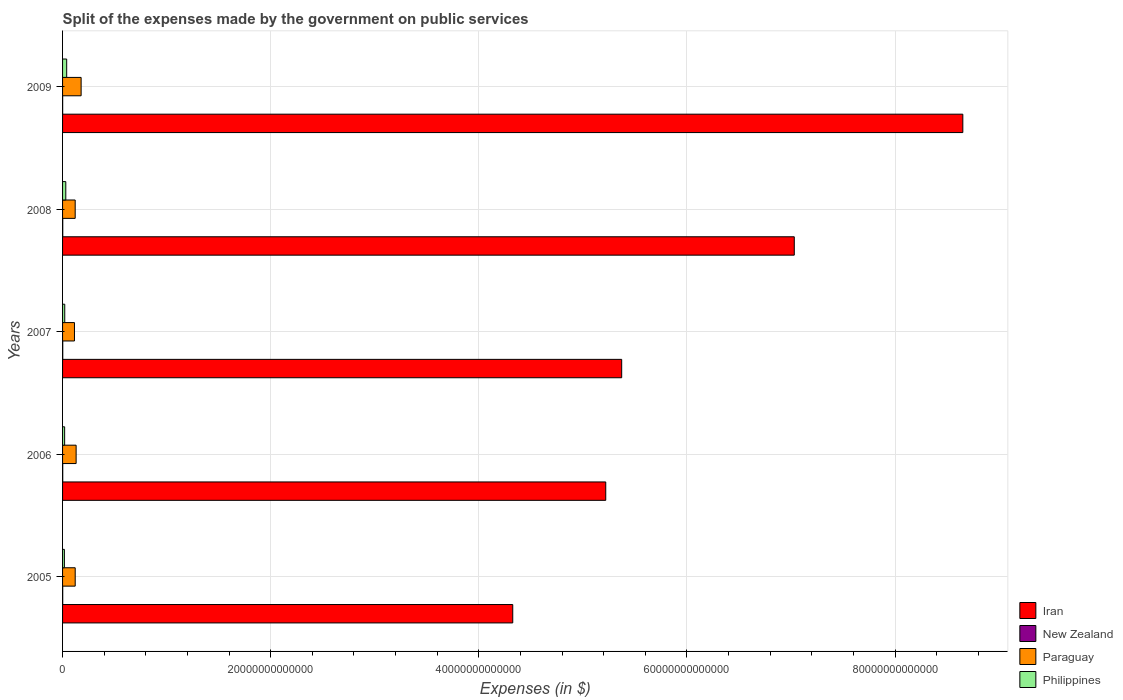How many groups of bars are there?
Make the answer very short. 5. Are the number of bars per tick equal to the number of legend labels?
Provide a succinct answer. Yes. Are the number of bars on each tick of the Y-axis equal?
Your response must be concise. Yes. How many bars are there on the 1st tick from the top?
Ensure brevity in your answer.  4. In how many cases, is the number of bars for a given year not equal to the number of legend labels?
Offer a terse response. 0. What is the expenses made by the government on public services in Paraguay in 2007?
Your answer should be very brief. 1.14e+12. Across all years, what is the maximum expenses made by the government on public services in Philippines?
Provide a succinct answer. 3.95e+11. Across all years, what is the minimum expenses made by the government on public services in Philippines?
Make the answer very short. 1.75e+11. What is the total expenses made by the government on public services in Paraguay in the graph?
Ensure brevity in your answer.  6.66e+12. What is the difference between the expenses made by the government on public services in New Zealand in 2005 and that in 2009?
Provide a short and direct response. 5.75e+09. What is the difference between the expenses made by the government on public services in Philippines in 2009 and the expenses made by the government on public services in New Zealand in 2007?
Make the answer very short. 3.78e+11. What is the average expenses made by the government on public services in Philippines per year?
Offer a very short reply. 2.58e+11. In the year 2008, what is the difference between the expenses made by the government on public services in Iran and expenses made by the government on public services in New Zealand?
Offer a very short reply. 7.03e+13. In how many years, is the expenses made by the government on public services in Philippines greater than 72000000000000 $?
Your answer should be compact. 0. What is the ratio of the expenses made by the government on public services in Philippines in 2006 to that in 2007?
Ensure brevity in your answer.  0.95. Is the expenses made by the government on public services in Iran in 2008 less than that in 2009?
Provide a short and direct response. Yes. Is the difference between the expenses made by the government on public services in Iran in 2005 and 2006 greater than the difference between the expenses made by the government on public services in New Zealand in 2005 and 2006?
Your answer should be compact. No. What is the difference between the highest and the second highest expenses made by the government on public services in Iran?
Provide a succinct answer. 1.62e+13. What is the difference between the highest and the lowest expenses made by the government on public services in Iran?
Make the answer very short. 4.32e+13. Is it the case that in every year, the sum of the expenses made by the government on public services in New Zealand and expenses made by the government on public services in Iran is greater than the sum of expenses made by the government on public services in Paraguay and expenses made by the government on public services in Philippines?
Give a very brief answer. Yes. What does the 3rd bar from the top in 2008 represents?
Your answer should be very brief. New Zealand. What does the 3rd bar from the bottom in 2007 represents?
Your response must be concise. Paraguay. How many bars are there?
Ensure brevity in your answer.  20. How many years are there in the graph?
Offer a very short reply. 5. What is the difference between two consecutive major ticks on the X-axis?
Provide a short and direct response. 2.00e+13. Are the values on the major ticks of X-axis written in scientific E-notation?
Offer a very short reply. No. Does the graph contain any zero values?
Offer a terse response. No. How are the legend labels stacked?
Offer a very short reply. Vertical. What is the title of the graph?
Make the answer very short. Split of the expenses made by the government on public services. What is the label or title of the X-axis?
Your answer should be very brief. Expenses (in $). What is the Expenses (in $) of Iran in 2005?
Offer a very short reply. 4.33e+13. What is the Expenses (in $) in New Zealand in 2005?
Provide a succinct answer. 1.40e+1. What is the Expenses (in $) of Paraguay in 2005?
Your response must be concise. 1.21e+12. What is the Expenses (in $) of Philippines in 2005?
Give a very brief answer. 1.75e+11. What is the Expenses (in $) of Iran in 2006?
Offer a terse response. 5.22e+13. What is the Expenses (in $) in New Zealand in 2006?
Your answer should be very brief. 1.58e+1. What is the Expenses (in $) of Paraguay in 2006?
Offer a terse response. 1.30e+12. What is the Expenses (in $) of Philippines in 2006?
Your answer should be compact. 1.99e+11. What is the Expenses (in $) of Iran in 2007?
Your answer should be compact. 5.37e+13. What is the Expenses (in $) of New Zealand in 2007?
Give a very brief answer. 1.77e+1. What is the Expenses (in $) in Paraguay in 2007?
Keep it short and to the point. 1.14e+12. What is the Expenses (in $) of Philippines in 2007?
Provide a succinct answer. 2.09e+11. What is the Expenses (in $) in Iran in 2008?
Keep it short and to the point. 7.03e+13. What is the Expenses (in $) in New Zealand in 2008?
Your response must be concise. 1.77e+1. What is the Expenses (in $) in Paraguay in 2008?
Your answer should be very brief. 1.21e+12. What is the Expenses (in $) of Philippines in 2008?
Offer a terse response. 3.11e+11. What is the Expenses (in $) of Iran in 2009?
Provide a succinct answer. 8.65e+13. What is the Expenses (in $) in New Zealand in 2009?
Offer a very short reply. 8.30e+09. What is the Expenses (in $) of Paraguay in 2009?
Offer a terse response. 1.78e+12. What is the Expenses (in $) of Philippines in 2009?
Provide a succinct answer. 3.95e+11. Across all years, what is the maximum Expenses (in $) in Iran?
Keep it short and to the point. 8.65e+13. Across all years, what is the maximum Expenses (in $) in New Zealand?
Offer a very short reply. 1.77e+1. Across all years, what is the maximum Expenses (in $) of Paraguay?
Keep it short and to the point. 1.78e+12. Across all years, what is the maximum Expenses (in $) of Philippines?
Offer a very short reply. 3.95e+11. Across all years, what is the minimum Expenses (in $) of Iran?
Provide a succinct answer. 4.33e+13. Across all years, what is the minimum Expenses (in $) in New Zealand?
Give a very brief answer. 8.30e+09. Across all years, what is the minimum Expenses (in $) in Paraguay?
Make the answer very short. 1.14e+12. Across all years, what is the minimum Expenses (in $) of Philippines?
Your answer should be compact. 1.75e+11. What is the total Expenses (in $) in Iran in the graph?
Make the answer very short. 3.06e+14. What is the total Expenses (in $) in New Zealand in the graph?
Provide a short and direct response. 7.35e+1. What is the total Expenses (in $) in Paraguay in the graph?
Give a very brief answer. 6.66e+12. What is the total Expenses (in $) of Philippines in the graph?
Ensure brevity in your answer.  1.29e+12. What is the difference between the Expenses (in $) in Iran in 2005 and that in 2006?
Ensure brevity in your answer.  -8.94e+12. What is the difference between the Expenses (in $) of New Zealand in 2005 and that in 2006?
Ensure brevity in your answer.  -1.75e+09. What is the difference between the Expenses (in $) in Paraguay in 2005 and that in 2006?
Provide a short and direct response. -8.92e+1. What is the difference between the Expenses (in $) of Philippines in 2005 and that in 2006?
Keep it short and to the point. -2.40e+1. What is the difference between the Expenses (in $) of Iran in 2005 and that in 2007?
Your answer should be very brief. -1.05e+13. What is the difference between the Expenses (in $) of New Zealand in 2005 and that in 2007?
Provide a short and direct response. -3.63e+09. What is the difference between the Expenses (in $) in Paraguay in 2005 and that in 2007?
Make the answer very short. 6.98e+1. What is the difference between the Expenses (in $) of Philippines in 2005 and that in 2007?
Your answer should be compact. -3.42e+1. What is the difference between the Expenses (in $) of Iran in 2005 and that in 2008?
Give a very brief answer. -2.71e+13. What is the difference between the Expenses (in $) in New Zealand in 2005 and that in 2008?
Give a very brief answer. -3.65e+09. What is the difference between the Expenses (in $) of Paraguay in 2005 and that in 2008?
Offer a terse response. 6.40e+08. What is the difference between the Expenses (in $) of Philippines in 2005 and that in 2008?
Your response must be concise. -1.36e+11. What is the difference between the Expenses (in $) of Iran in 2005 and that in 2009?
Your response must be concise. -4.32e+13. What is the difference between the Expenses (in $) of New Zealand in 2005 and that in 2009?
Ensure brevity in your answer.  5.75e+09. What is the difference between the Expenses (in $) in Paraguay in 2005 and that in 2009?
Keep it short and to the point. -5.70e+11. What is the difference between the Expenses (in $) of Philippines in 2005 and that in 2009?
Offer a terse response. -2.20e+11. What is the difference between the Expenses (in $) of Iran in 2006 and that in 2007?
Offer a very short reply. -1.53e+12. What is the difference between the Expenses (in $) of New Zealand in 2006 and that in 2007?
Your answer should be very brief. -1.88e+09. What is the difference between the Expenses (in $) in Paraguay in 2006 and that in 2007?
Keep it short and to the point. 1.59e+11. What is the difference between the Expenses (in $) in Philippines in 2006 and that in 2007?
Your answer should be compact. -1.02e+1. What is the difference between the Expenses (in $) of Iran in 2006 and that in 2008?
Your answer should be very brief. -1.81e+13. What is the difference between the Expenses (in $) of New Zealand in 2006 and that in 2008?
Make the answer very short. -1.90e+09. What is the difference between the Expenses (in $) in Paraguay in 2006 and that in 2008?
Offer a very short reply. 8.98e+1. What is the difference between the Expenses (in $) in Philippines in 2006 and that in 2008?
Provide a short and direct response. -1.12e+11. What is the difference between the Expenses (in $) in Iran in 2006 and that in 2009?
Your answer should be very brief. -3.43e+13. What is the difference between the Expenses (in $) in New Zealand in 2006 and that in 2009?
Make the answer very short. 7.49e+09. What is the difference between the Expenses (in $) in Paraguay in 2006 and that in 2009?
Give a very brief answer. -4.81e+11. What is the difference between the Expenses (in $) of Philippines in 2006 and that in 2009?
Your response must be concise. -1.96e+11. What is the difference between the Expenses (in $) of Iran in 2007 and that in 2008?
Offer a very short reply. -1.66e+13. What is the difference between the Expenses (in $) of New Zealand in 2007 and that in 2008?
Give a very brief answer. -1.65e+07. What is the difference between the Expenses (in $) of Paraguay in 2007 and that in 2008?
Your answer should be very brief. -6.91e+1. What is the difference between the Expenses (in $) in Philippines in 2007 and that in 2008?
Your response must be concise. -1.01e+11. What is the difference between the Expenses (in $) in Iran in 2007 and that in 2009?
Ensure brevity in your answer.  -3.28e+13. What is the difference between the Expenses (in $) of New Zealand in 2007 and that in 2009?
Ensure brevity in your answer.  9.38e+09. What is the difference between the Expenses (in $) in Paraguay in 2007 and that in 2009?
Give a very brief answer. -6.40e+11. What is the difference between the Expenses (in $) in Philippines in 2007 and that in 2009?
Your answer should be very brief. -1.86e+11. What is the difference between the Expenses (in $) in Iran in 2008 and that in 2009?
Keep it short and to the point. -1.62e+13. What is the difference between the Expenses (in $) of New Zealand in 2008 and that in 2009?
Make the answer very short. 9.39e+09. What is the difference between the Expenses (in $) in Paraguay in 2008 and that in 2009?
Your answer should be compact. -5.70e+11. What is the difference between the Expenses (in $) of Philippines in 2008 and that in 2009?
Your answer should be very brief. -8.45e+1. What is the difference between the Expenses (in $) of Iran in 2005 and the Expenses (in $) of New Zealand in 2006?
Provide a short and direct response. 4.32e+13. What is the difference between the Expenses (in $) of Iran in 2005 and the Expenses (in $) of Paraguay in 2006?
Your answer should be very brief. 4.20e+13. What is the difference between the Expenses (in $) of Iran in 2005 and the Expenses (in $) of Philippines in 2006?
Your answer should be very brief. 4.31e+13. What is the difference between the Expenses (in $) in New Zealand in 2005 and the Expenses (in $) in Paraguay in 2006?
Provide a succinct answer. -1.29e+12. What is the difference between the Expenses (in $) of New Zealand in 2005 and the Expenses (in $) of Philippines in 2006?
Offer a very short reply. -1.85e+11. What is the difference between the Expenses (in $) in Paraguay in 2005 and the Expenses (in $) in Philippines in 2006?
Your response must be concise. 1.01e+12. What is the difference between the Expenses (in $) of Iran in 2005 and the Expenses (in $) of New Zealand in 2007?
Keep it short and to the point. 4.32e+13. What is the difference between the Expenses (in $) of Iran in 2005 and the Expenses (in $) of Paraguay in 2007?
Ensure brevity in your answer.  4.21e+13. What is the difference between the Expenses (in $) in Iran in 2005 and the Expenses (in $) in Philippines in 2007?
Give a very brief answer. 4.30e+13. What is the difference between the Expenses (in $) of New Zealand in 2005 and the Expenses (in $) of Paraguay in 2007?
Provide a succinct answer. -1.13e+12. What is the difference between the Expenses (in $) of New Zealand in 2005 and the Expenses (in $) of Philippines in 2007?
Offer a terse response. -1.95e+11. What is the difference between the Expenses (in $) of Paraguay in 2005 and the Expenses (in $) of Philippines in 2007?
Offer a very short reply. 1.00e+12. What is the difference between the Expenses (in $) of Iran in 2005 and the Expenses (in $) of New Zealand in 2008?
Your response must be concise. 4.32e+13. What is the difference between the Expenses (in $) in Iran in 2005 and the Expenses (in $) in Paraguay in 2008?
Provide a short and direct response. 4.20e+13. What is the difference between the Expenses (in $) in Iran in 2005 and the Expenses (in $) in Philippines in 2008?
Offer a very short reply. 4.29e+13. What is the difference between the Expenses (in $) in New Zealand in 2005 and the Expenses (in $) in Paraguay in 2008?
Provide a succinct answer. -1.20e+12. What is the difference between the Expenses (in $) in New Zealand in 2005 and the Expenses (in $) in Philippines in 2008?
Your response must be concise. -2.97e+11. What is the difference between the Expenses (in $) of Paraguay in 2005 and the Expenses (in $) of Philippines in 2008?
Keep it short and to the point. 9.03e+11. What is the difference between the Expenses (in $) of Iran in 2005 and the Expenses (in $) of New Zealand in 2009?
Provide a short and direct response. 4.33e+13. What is the difference between the Expenses (in $) of Iran in 2005 and the Expenses (in $) of Paraguay in 2009?
Offer a very short reply. 4.15e+13. What is the difference between the Expenses (in $) in Iran in 2005 and the Expenses (in $) in Philippines in 2009?
Provide a succinct answer. 4.29e+13. What is the difference between the Expenses (in $) of New Zealand in 2005 and the Expenses (in $) of Paraguay in 2009?
Your response must be concise. -1.77e+12. What is the difference between the Expenses (in $) in New Zealand in 2005 and the Expenses (in $) in Philippines in 2009?
Keep it short and to the point. -3.81e+11. What is the difference between the Expenses (in $) in Paraguay in 2005 and the Expenses (in $) in Philippines in 2009?
Give a very brief answer. 8.18e+11. What is the difference between the Expenses (in $) in Iran in 2006 and the Expenses (in $) in New Zealand in 2007?
Offer a very short reply. 5.22e+13. What is the difference between the Expenses (in $) of Iran in 2006 and the Expenses (in $) of Paraguay in 2007?
Ensure brevity in your answer.  5.11e+13. What is the difference between the Expenses (in $) of Iran in 2006 and the Expenses (in $) of Philippines in 2007?
Provide a succinct answer. 5.20e+13. What is the difference between the Expenses (in $) of New Zealand in 2006 and the Expenses (in $) of Paraguay in 2007?
Offer a very short reply. -1.13e+12. What is the difference between the Expenses (in $) in New Zealand in 2006 and the Expenses (in $) in Philippines in 2007?
Keep it short and to the point. -1.94e+11. What is the difference between the Expenses (in $) of Paraguay in 2006 and the Expenses (in $) of Philippines in 2007?
Provide a short and direct response. 1.09e+12. What is the difference between the Expenses (in $) in Iran in 2006 and the Expenses (in $) in New Zealand in 2008?
Give a very brief answer. 5.22e+13. What is the difference between the Expenses (in $) in Iran in 2006 and the Expenses (in $) in Paraguay in 2008?
Your answer should be compact. 5.10e+13. What is the difference between the Expenses (in $) in Iran in 2006 and the Expenses (in $) in Philippines in 2008?
Keep it short and to the point. 5.19e+13. What is the difference between the Expenses (in $) in New Zealand in 2006 and the Expenses (in $) in Paraguay in 2008?
Provide a short and direct response. -1.20e+12. What is the difference between the Expenses (in $) in New Zealand in 2006 and the Expenses (in $) in Philippines in 2008?
Keep it short and to the point. -2.95e+11. What is the difference between the Expenses (in $) in Paraguay in 2006 and the Expenses (in $) in Philippines in 2008?
Ensure brevity in your answer.  9.92e+11. What is the difference between the Expenses (in $) in Iran in 2006 and the Expenses (in $) in New Zealand in 2009?
Your response must be concise. 5.22e+13. What is the difference between the Expenses (in $) in Iran in 2006 and the Expenses (in $) in Paraguay in 2009?
Provide a succinct answer. 5.04e+13. What is the difference between the Expenses (in $) of Iran in 2006 and the Expenses (in $) of Philippines in 2009?
Provide a succinct answer. 5.18e+13. What is the difference between the Expenses (in $) in New Zealand in 2006 and the Expenses (in $) in Paraguay in 2009?
Offer a terse response. -1.77e+12. What is the difference between the Expenses (in $) of New Zealand in 2006 and the Expenses (in $) of Philippines in 2009?
Give a very brief answer. -3.80e+11. What is the difference between the Expenses (in $) of Paraguay in 2006 and the Expenses (in $) of Philippines in 2009?
Offer a terse response. 9.07e+11. What is the difference between the Expenses (in $) in Iran in 2007 and the Expenses (in $) in New Zealand in 2008?
Your response must be concise. 5.37e+13. What is the difference between the Expenses (in $) in Iran in 2007 and the Expenses (in $) in Paraguay in 2008?
Make the answer very short. 5.25e+13. What is the difference between the Expenses (in $) in Iran in 2007 and the Expenses (in $) in Philippines in 2008?
Provide a short and direct response. 5.34e+13. What is the difference between the Expenses (in $) of New Zealand in 2007 and the Expenses (in $) of Paraguay in 2008?
Your response must be concise. -1.20e+12. What is the difference between the Expenses (in $) of New Zealand in 2007 and the Expenses (in $) of Philippines in 2008?
Your response must be concise. -2.93e+11. What is the difference between the Expenses (in $) of Paraguay in 2007 and the Expenses (in $) of Philippines in 2008?
Your answer should be very brief. 8.33e+11. What is the difference between the Expenses (in $) of Iran in 2007 and the Expenses (in $) of New Zealand in 2009?
Your answer should be compact. 5.37e+13. What is the difference between the Expenses (in $) in Iran in 2007 and the Expenses (in $) in Paraguay in 2009?
Provide a short and direct response. 5.19e+13. What is the difference between the Expenses (in $) in Iran in 2007 and the Expenses (in $) in Philippines in 2009?
Your answer should be very brief. 5.33e+13. What is the difference between the Expenses (in $) of New Zealand in 2007 and the Expenses (in $) of Paraguay in 2009?
Keep it short and to the point. -1.77e+12. What is the difference between the Expenses (in $) in New Zealand in 2007 and the Expenses (in $) in Philippines in 2009?
Offer a very short reply. -3.78e+11. What is the difference between the Expenses (in $) in Paraguay in 2007 and the Expenses (in $) in Philippines in 2009?
Provide a succinct answer. 7.48e+11. What is the difference between the Expenses (in $) in Iran in 2008 and the Expenses (in $) in New Zealand in 2009?
Give a very brief answer. 7.03e+13. What is the difference between the Expenses (in $) of Iran in 2008 and the Expenses (in $) of Paraguay in 2009?
Your response must be concise. 6.85e+13. What is the difference between the Expenses (in $) of Iran in 2008 and the Expenses (in $) of Philippines in 2009?
Make the answer very short. 6.99e+13. What is the difference between the Expenses (in $) of New Zealand in 2008 and the Expenses (in $) of Paraguay in 2009?
Give a very brief answer. -1.77e+12. What is the difference between the Expenses (in $) in New Zealand in 2008 and the Expenses (in $) in Philippines in 2009?
Provide a succinct answer. -3.78e+11. What is the difference between the Expenses (in $) of Paraguay in 2008 and the Expenses (in $) of Philippines in 2009?
Your answer should be compact. 8.18e+11. What is the average Expenses (in $) in Iran per year?
Provide a short and direct response. 6.12e+13. What is the average Expenses (in $) in New Zealand per year?
Make the answer very short. 1.47e+1. What is the average Expenses (in $) of Paraguay per year?
Make the answer very short. 1.33e+12. What is the average Expenses (in $) of Philippines per year?
Your response must be concise. 2.58e+11. In the year 2005, what is the difference between the Expenses (in $) in Iran and Expenses (in $) in New Zealand?
Make the answer very short. 4.32e+13. In the year 2005, what is the difference between the Expenses (in $) of Iran and Expenses (in $) of Paraguay?
Offer a terse response. 4.20e+13. In the year 2005, what is the difference between the Expenses (in $) in Iran and Expenses (in $) in Philippines?
Provide a succinct answer. 4.31e+13. In the year 2005, what is the difference between the Expenses (in $) of New Zealand and Expenses (in $) of Paraguay?
Make the answer very short. -1.20e+12. In the year 2005, what is the difference between the Expenses (in $) of New Zealand and Expenses (in $) of Philippines?
Make the answer very short. -1.61e+11. In the year 2005, what is the difference between the Expenses (in $) in Paraguay and Expenses (in $) in Philippines?
Make the answer very short. 1.04e+12. In the year 2006, what is the difference between the Expenses (in $) in Iran and Expenses (in $) in New Zealand?
Your answer should be very brief. 5.22e+13. In the year 2006, what is the difference between the Expenses (in $) of Iran and Expenses (in $) of Paraguay?
Offer a terse response. 5.09e+13. In the year 2006, what is the difference between the Expenses (in $) of Iran and Expenses (in $) of Philippines?
Your answer should be very brief. 5.20e+13. In the year 2006, what is the difference between the Expenses (in $) in New Zealand and Expenses (in $) in Paraguay?
Keep it short and to the point. -1.29e+12. In the year 2006, what is the difference between the Expenses (in $) of New Zealand and Expenses (in $) of Philippines?
Your response must be concise. -1.83e+11. In the year 2006, what is the difference between the Expenses (in $) in Paraguay and Expenses (in $) in Philippines?
Offer a very short reply. 1.10e+12. In the year 2007, what is the difference between the Expenses (in $) of Iran and Expenses (in $) of New Zealand?
Make the answer very short. 5.37e+13. In the year 2007, what is the difference between the Expenses (in $) in Iran and Expenses (in $) in Paraguay?
Make the answer very short. 5.26e+13. In the year 2007, what is the difference between the Expenses (in $) in Iran and Expenses (in $) in Philippines?
Offer a very short reply. 5.35e+13. In the year 2007, what is the difference between the Expenses (in $) in New Zealand and Expenses (in $) in Paraguay?
Make the answer very short. -1.13e+12. In the year 2007, what is the difference between the Expenses (in $) of New Zealand and Expenses (in $) of Philippines?
Your answer should be compact. -1.92e+11. In the year 2007, what is the difference between the Expenses (in $) in Paraguay and Expenses (in $) in Philippines?
Keep it short and to the point. 9.34e+11. In the year 2008, what is the difference between the Expenses (in $) in Iran and Expenses (in $) in New Zealand?
Provide a succinct answer. 7.03e+13. In the year 2008, what is the difference between the Expenses (in $) in Iran and Expenses (in $) in Paraguay?
Offer a very short reply. 6.91e+13. In the year 2008, what is the difference between the Expenses (in $) in Iran and Expenses (in $) in Philippines?
Provide a succinct answer. 7.00e+13. In the year 2008, what is the difference between the Expenses (in $) of New Zealand and Expenses (in $) of Paraguay?
Make the answer very short. -1.20e+12. In the year 2008, what is the difference between the Expenses (in $) in New Zealand and Expenses (in $) in Philippines?
Your response must be concise. -2.93e+11. In the year 2008, what is the difference between the Expenses (in $) in Paraguay and Expenses (in $) in Philippines?
Make the answer very short. 9.02e+11. In the year 2009, what is the difference between the Expenses (in $) of Iran and Expenses (in $) of New Zealand?
Ensure brevity in your answer.  8.65e+13. In the year 2009, what is the difference between the Expenses (in $) of Iran and Expenses (in $) of Paraguay?
Provide a succinct answer. 8.47e+13. In the year 2009, what is the difference between the Expenses (in $) of Iran and Expenses (in $) of Philippines?
Make the answer very short. 8.61e+13. In the year 2009, what is the difference between the Expenses (in $) of New Zealand and Expenses (in $) of Paraguay?
Your answer should be compact. -1.78e+12. In the year 2009, what is the difference between the Expenses (in $) of New Zealand and Expenses (in $) of Philippines?
Offer a very short reply. -3.87e+11. In the year 2009, what is the difference between the Expenses (in $) of Paraguay and Expenses (in $) of Philippines?
Ensure brevity in your answer.  1.39e+12. What is the ratio of the Expenses (in $) in Iran in 2005 to that in 2006?
Provide a short and direct response. 0.83. What is the ratio of the Expenses (in $) of New Zealand in 2005 to that in 2006?
Your answer should be compact. 0.89. What is the ratio of the Expenses (in $) of Paraguay in 2005 to that in 2006?
Keep it short and to the point. 0.93. What is the ratio of the Expenses (in $) in Philippines in 2005 to that in 2006?
Your answer should be compact. 0.88. What is the ratio of the Expenses (in $) of Iran in 2005 to that in 2007?
Offer a terse response. 0.81. What is the ratio of the Expenses (in $) in New Zealand in 2005 to that in 2007?
Provide a short and direct response. 0.79. What is the ratio of the Expenses (in $) in Paraguay in 2005 to that in 2007?
Provide a short and direct response. 1.06. What is the ratio of the Expenses (in $) of Philippines in 2005 to that in 2007?
Your answer should be compact. 0.84. What is the ratio of the Expenses (in $) of Iran in 2005 to that in 2008?
Provide a succinct answer. 0.62. What is the ratio of the Expenses (in $) of New Zealand in 2005 to that in 2008?
Your response must be concise. 0.79. What is the ratio of the Expenses (in $) of Philippines in 2005 to that in 2008?
Your response must be concise. 0.56. What is the ratio of the Expenses (in $) of Iran in 2005 to that in 2009?
Provide a short and direct response. 0.5. What is the ratio of the Expenses (in $) of New Zealand in 2005 to that in 2009?
Ensure brevity in your answer.  1.69. What is the ratio of the Expenses (in $) of Paraguay in 2005 to that in 2009?
Your response must be concise. 0.68. What is the ratio of the Expenses (in $) in Philippines in 2005 to that in 2009?
Ensure brevity in your answer.  0.44. What is the ratio of the Expenses (in $) in Iran in 2006 to that in 2007?
Keep it short and to the point. 0.97. What is the ratio of the Expenses (in $) of New Zealand in 2006 to that in 2007?
Offer a very short reply. 0.89. What is the ratio of the Expenses (in $) in Paraguay in 2006 to that in 2007?
Give a very brief answer. 1.14. What is the ratio of the Expenses (in $) in Philippines in 2006 to that in 2007?
Your answer should be very brief. 0.95. What is the ratio of the Expenses (in $) of Iran in 2006 to that in 2008?
Keep it short and to the point. 0.74. What is the ratio of the Expenses (in $) in New Zealand in 2006 to that in 2008?
Give a very brief answer. 0.89. What is the ratio of the Expenses (in $) of Paraguay in 2006 to that in 2008?
Keep it short and to the point. 1.07. What is the ratio of the Expenses (in $) in Philippines in 2006 to that in 2008?
Ensure brevity in your answer.  0.64. What is the ratio of the Expenses (in $) of Iran in 2006 to that in 2009?
Keep it short and to the point. 0.6. What is the ratio of the Expenses (in $) in New Zealand in 2006 to that in 2009?
Provide a short and direct response. 1.9. What is the ratio of the Expenses (in $) in Paraguay in 2006 to that in 2009?
Offer a terse response. 0.73. What is the ratio of the Expenses (in $) in Philippines in 2006 to that in 2009?
Your answer should be very brief. 0.5. What is the ratio of the Expenses (in $) in Iran in 2007 to that in 2008?
Your response must be concise. 0.76. What is the ratio of the Expenses (in $) in New Zealand in 2007 to that in 2008?
Give a very brief answer. 1. What is the ratio of the Expenses (in $) of Paraguay in 2007 to that in 2008?
Ensure brevity in your answer.  0.94. What is the ratio of the Expenses (in $) in Philippines in 2007 to that in 2008?
Give a very brief answer. 0.67. What is the ratio of the Expenses (in $) in Iran in 2007 to that in 2009?
Ensure brevity in your answer.  0.62. What is the ratio of the Expenses (in $) in New Zealand in 2007 to that in 2009?
Make the answer very short. 2.13. What is the ratio of the Expenses (in $) in Paraguay in 2007 to that in 2009?
Offer a terse response. 0.64. What is the ratio of the Expenses (in $) in Philippines in 2007 to that in 2009?
Keep it short and to the point. 0.53. What is the ratio of the Expenses (in $) of Iran in 2008 to that in 2009?
Offer a very short reply. 0.81. What is the ratio of the Expenses (in $) of New Zealand in 2008 to that in 2009?
Ensure brevity in your answer.  2.13. What is the ratio of the Expenses (in $) in Paraguay in 2008 to that in 2009?
Your answer should be compact. 0.68. What is the ratio of the Expenses (in $) in Philippines in 2008 to that in 2009?
Make the answer very short. 0.79. What is the difference between the highest and the second highest Expenses (in $) of Iran?
Your response must be concise. 1.62e+13. What is the difference between the highest and the second highest Expenses (in $) of New Zealand?
Keep it short and to the point. 1.65e+07. What is the difference between the highest and the second highest Expenses (in $) in Paraguay?
Your response must be concise. 4.81e+11. What is the difference between the highest and the second highest Expenses (in $) of Philippines?
Keep it short and to the point. 8.45e+1. What is the difference between the highest and the lowest Expenses (in $) in Iran?
Keep it short and to the point. 4.32e+13. What is the difference between the highest and the lowest Expenses (in $) in New Zealand?
Ensure brevity in your answer.  9.39e+09. What is the difference between the highest and the lowest Expenses (in $) of Paraguay?
Offer a very short reply. 6.40e+11. What is the difference between the highest and the lowest Expenses (in $) of Philippines?
Provide a succinct answer. 2.20e+11. 